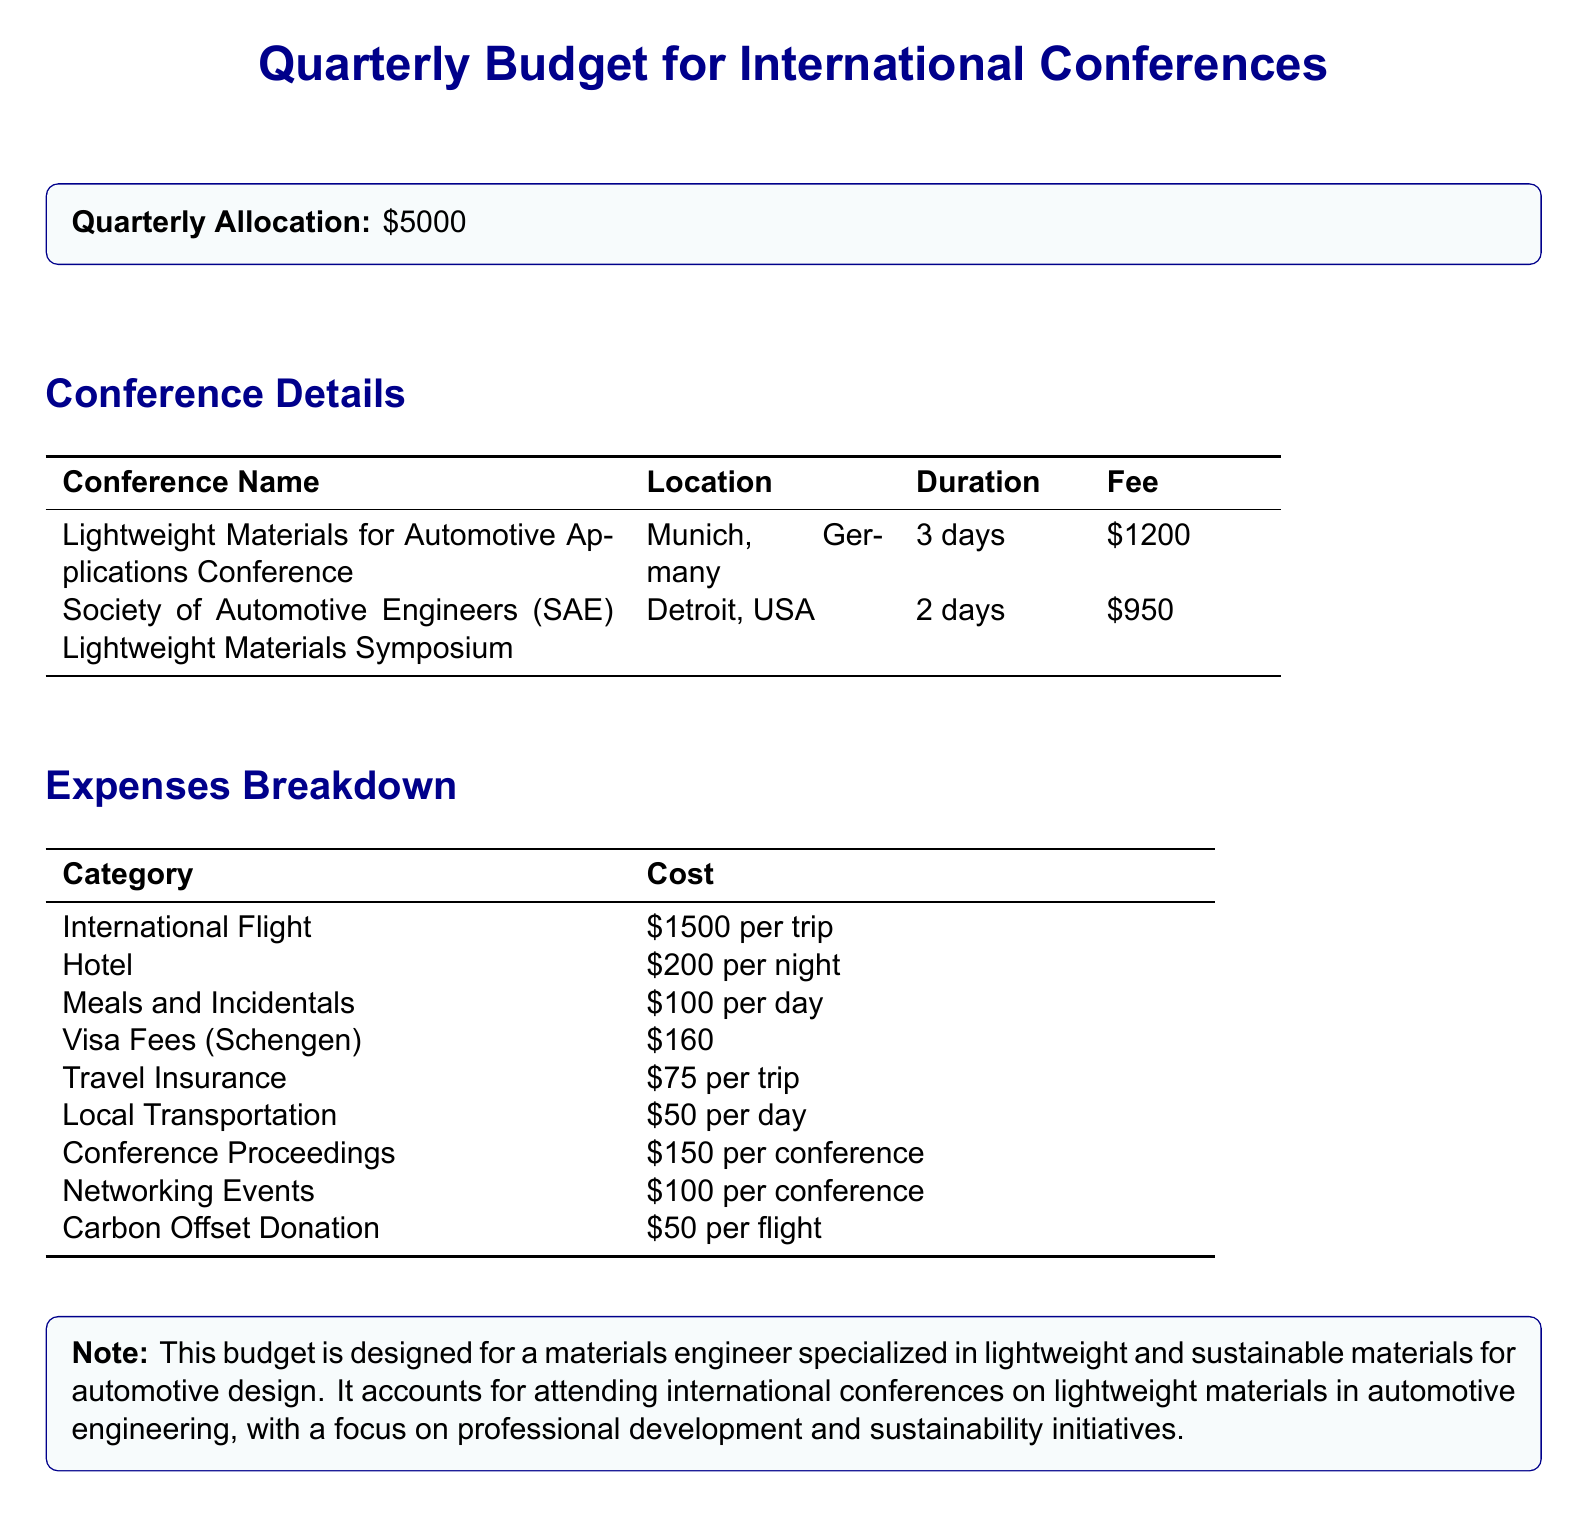What is the quarterly allocation? The document states a quarterly allocation of $5000 for attending international conferences.
Answer: $5000 How much is the fee for the SAE Lightweight Materials Symposium? The fee for the SAE Lightweight Materials Symposium is listed as $950 in the document.
Answer: $950 What is the location of the Lightweight Materials for Automotive Applications Conference? The document specifies that the conference will be held in Munich, Germany.
Answer: Munich, Germany What is the duration of the Lightweight Materials for Automotive Applications Conference? The duration is stated as 3 days in the conference details section.
Answer: 3 days How much does local transportation cost per day? The document mentions that local transportation costs $50 per day.
Answer: $50 What is the total cost for meals and incidentals for a 3-day conference? The meals and incidentals cost $100 per day, totaling $300 for the 3 days of the conference.
Answer: $300 How many conferences are listed in the document? The document includes two conferences listed under conference details.
Answer: 2 What is the cost of visa fees mentioned in the budget? The document indicates that visa fees (Schengen) cost $160.
Answer: $160 How much is allocated for carbon offset donation per flight? According to the document, the carbon offset donation is $50 per flight.
Answer: $50 What categories are included in the expenses breakdown? The expenses breakdown includes categories like International Flight, Hotel, Meals and Incidentals, and more.
Answer: International Flight, Hotel, Meals and Incidentals, Visa Fees, Travel Insurance, Local Transportation, Conference Proceedings, Networking Events, Carbon Offset Donation 